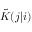<formula> <loc_0><loc_0><loc_500><loc_500>\tilde { K } ( j | i )</formula> 